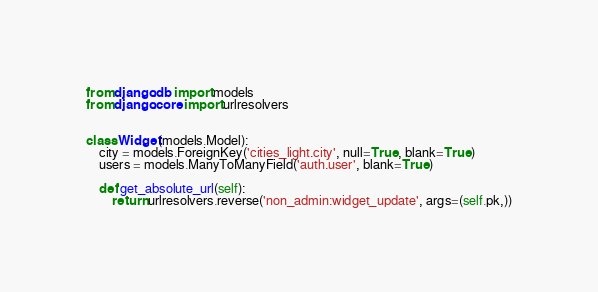<code> <loc_0><loc_0><loc_500><loc_500><_Python_>from django.db import models
from django.core import urlresolvers


class Widget(models.Model):
    city = models.ForeignKey('cities_light.city', null=True, blank=True)
    users = models.ManyToManyField('auth.user', blank=True)

    def get_absolute_url(self):
        return urlresolvers.reverse('non_admin:widget_update', args=(self.pk,))
</code> 